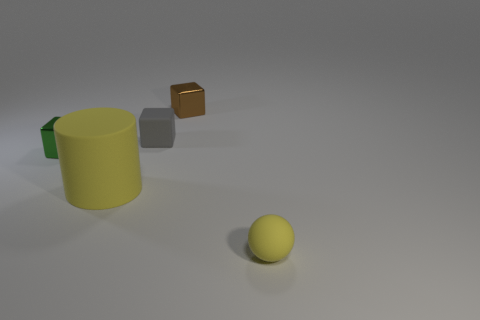What materials do the objects in the image appear to be made of? The objects in the image seem to be rendered with different materials. The cylindrical object on the left appears to have a matte finish, indicative of a plastic or ceramic material. The tiny gray block has a slightly reflective surface, suggesting it could be made of metal. The larger brown cube in the air also has a reflective quality, which implies a metallic nature. Lastly, the spherical object on the ground has a diffuse surface, resembling a rubber or matte plastic material. 